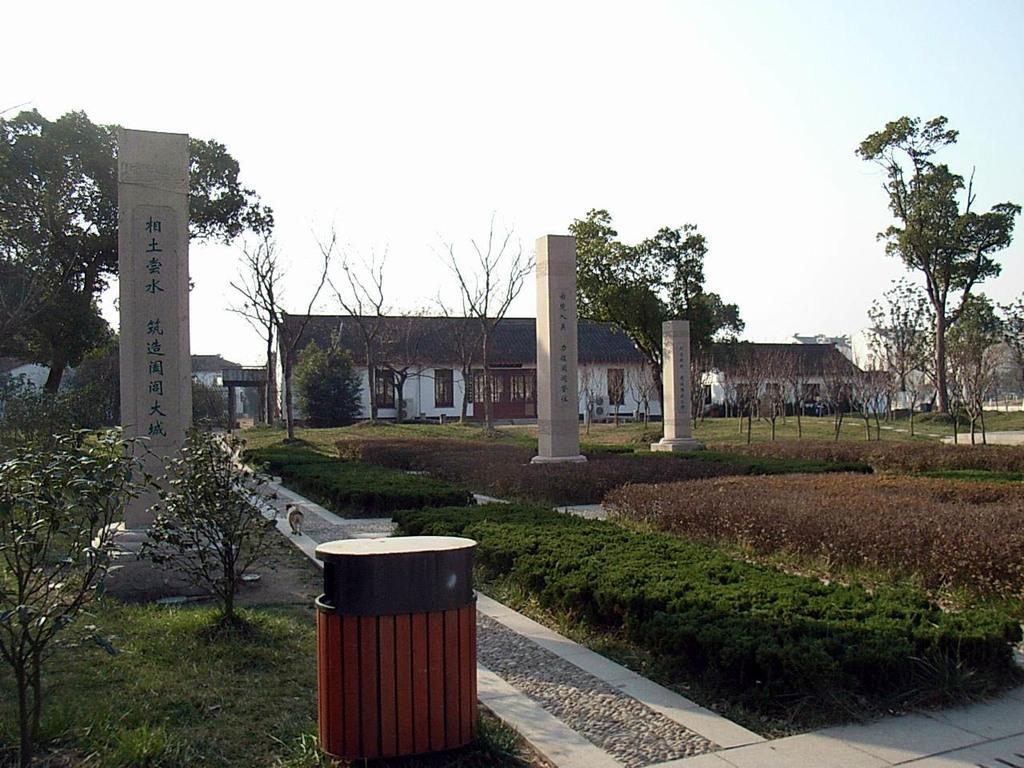In one or two sentences, can you explain what this image depicts? In this image there is grass, pillars, trees and houses and there is a dog on the pavement. 